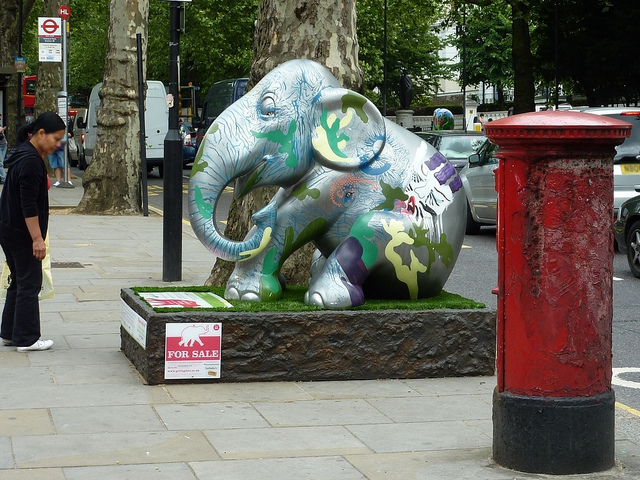What color is the hydrants? The fire hydrant depicted in the image is artistically painted with multiple colors including red, which is traditionally associated with fire hydrants for visibility and standardization purposes. 